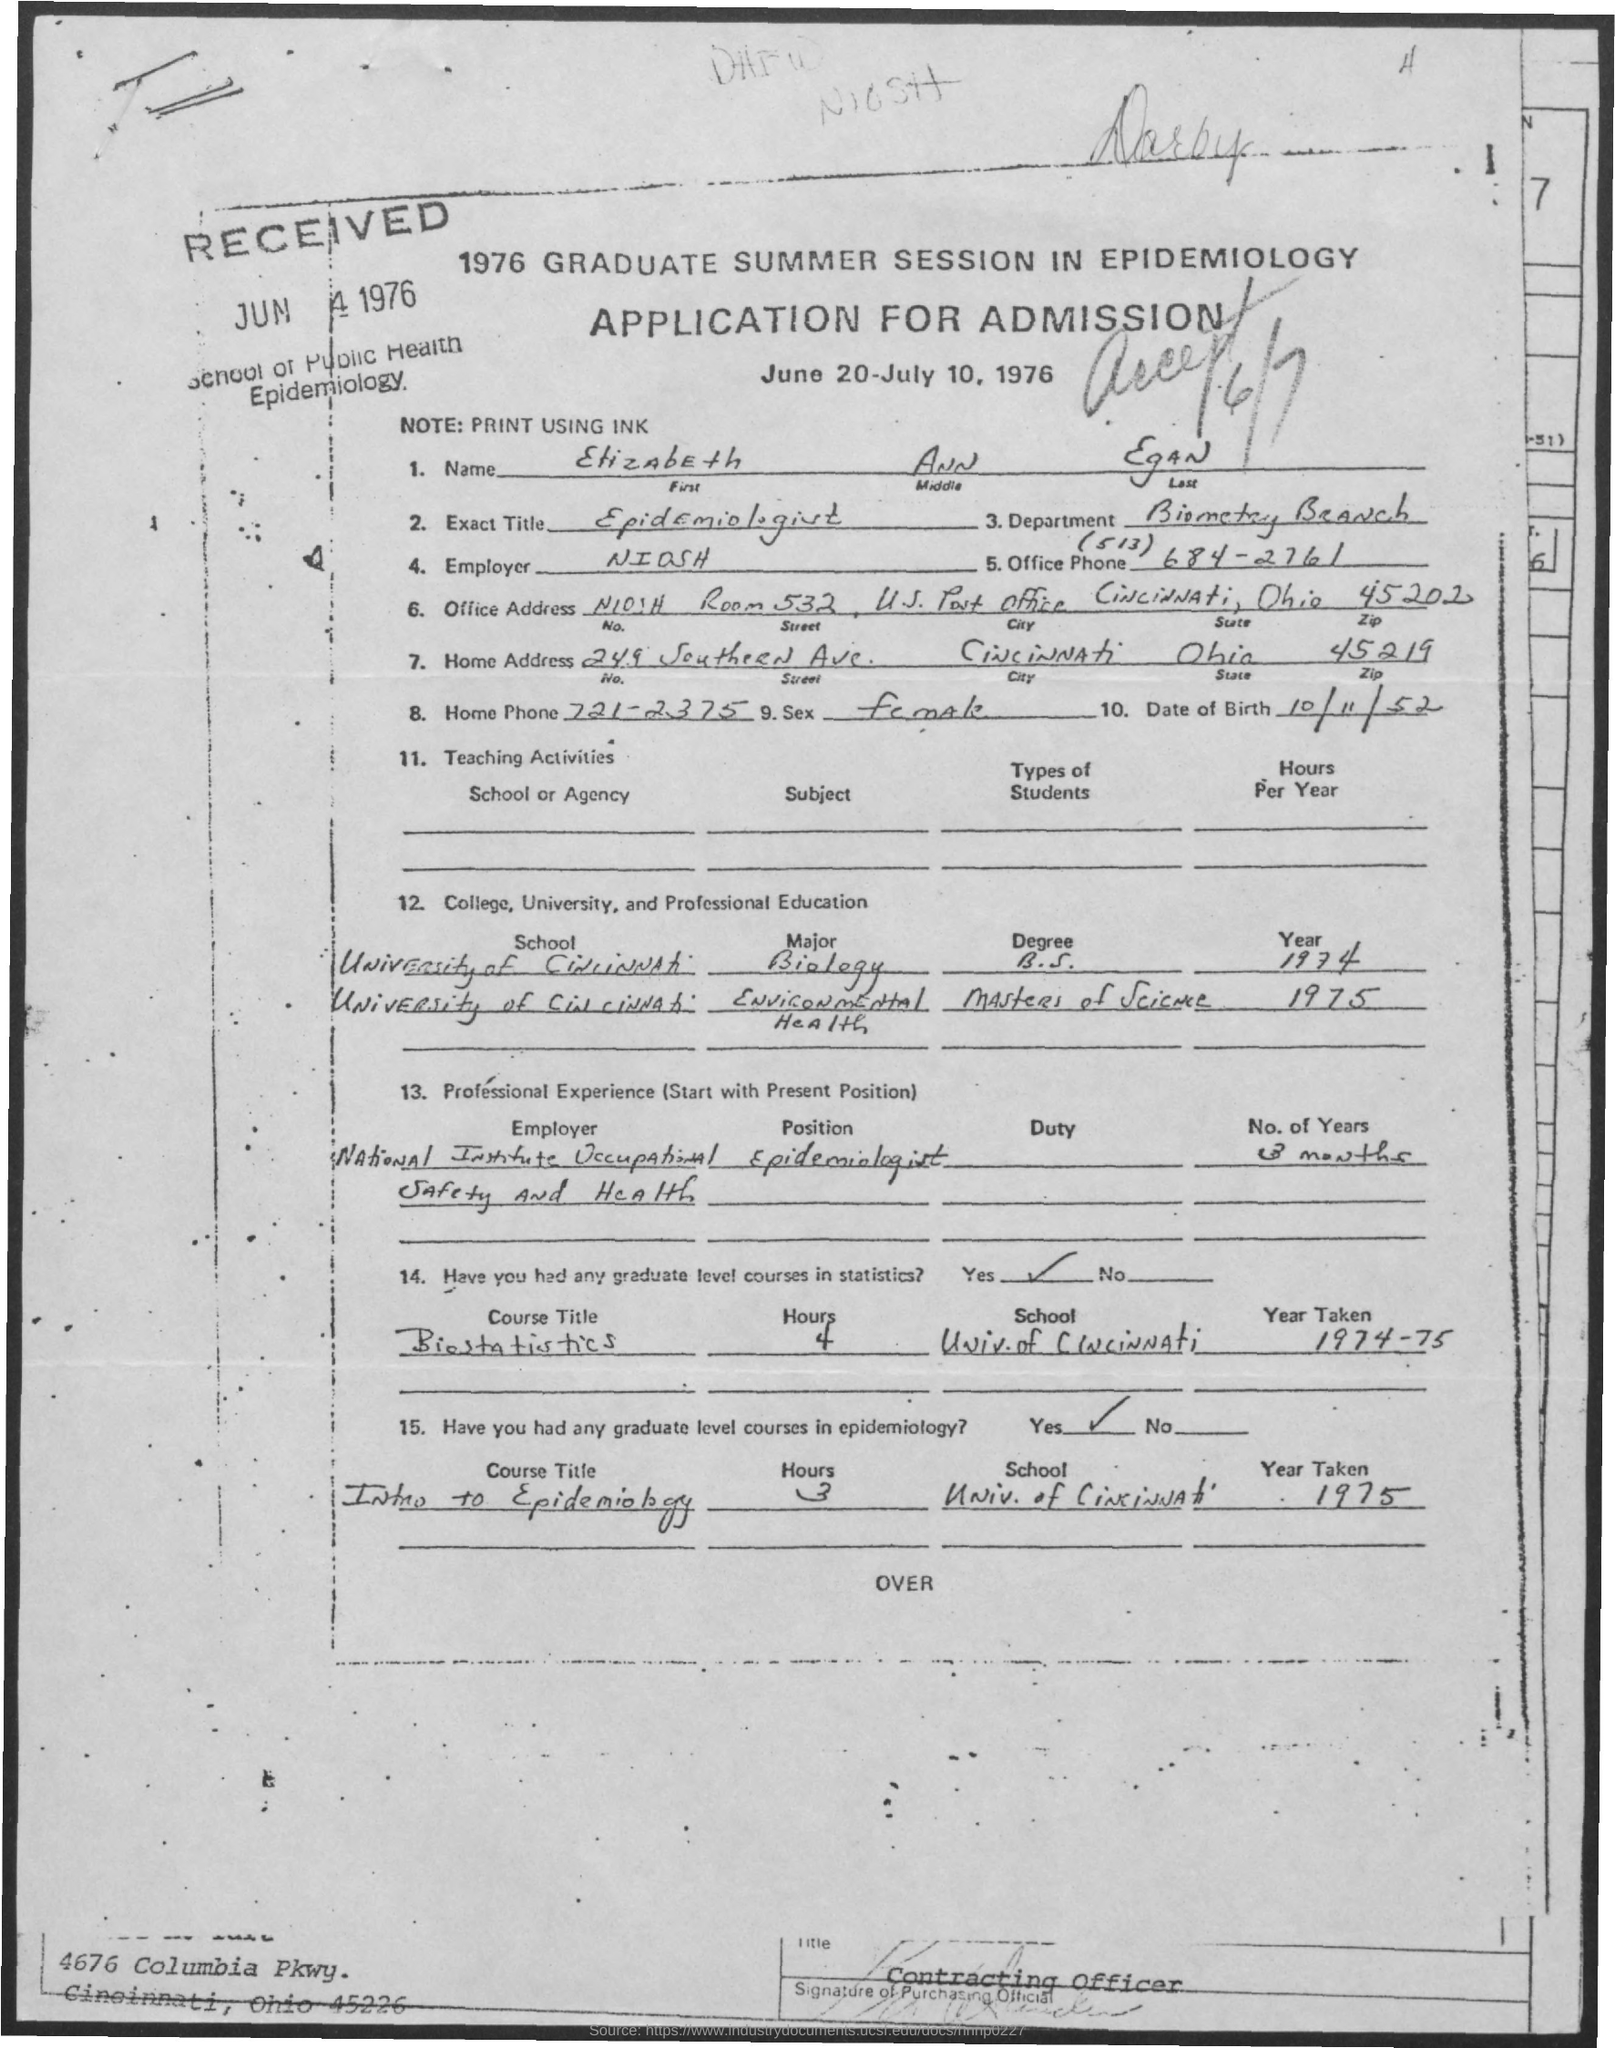Identify some key points in this picture. The middle name is Ann. The employer in this case is the National Institute for Occupational Safety and Health (NIOSH). Cincinnati is the city. The Biometry Branch is the department. The last name of the person is Egan. 